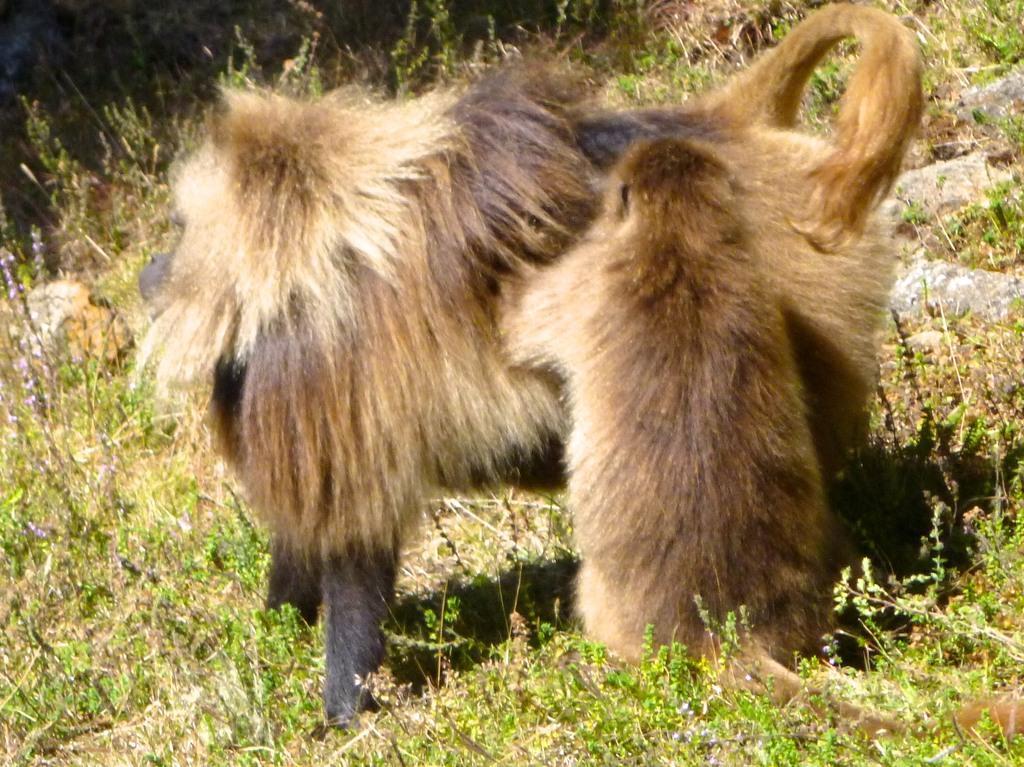In one or two sentences, can you explain what this image depicts? In the image there is a monkey standing on a grassland. 